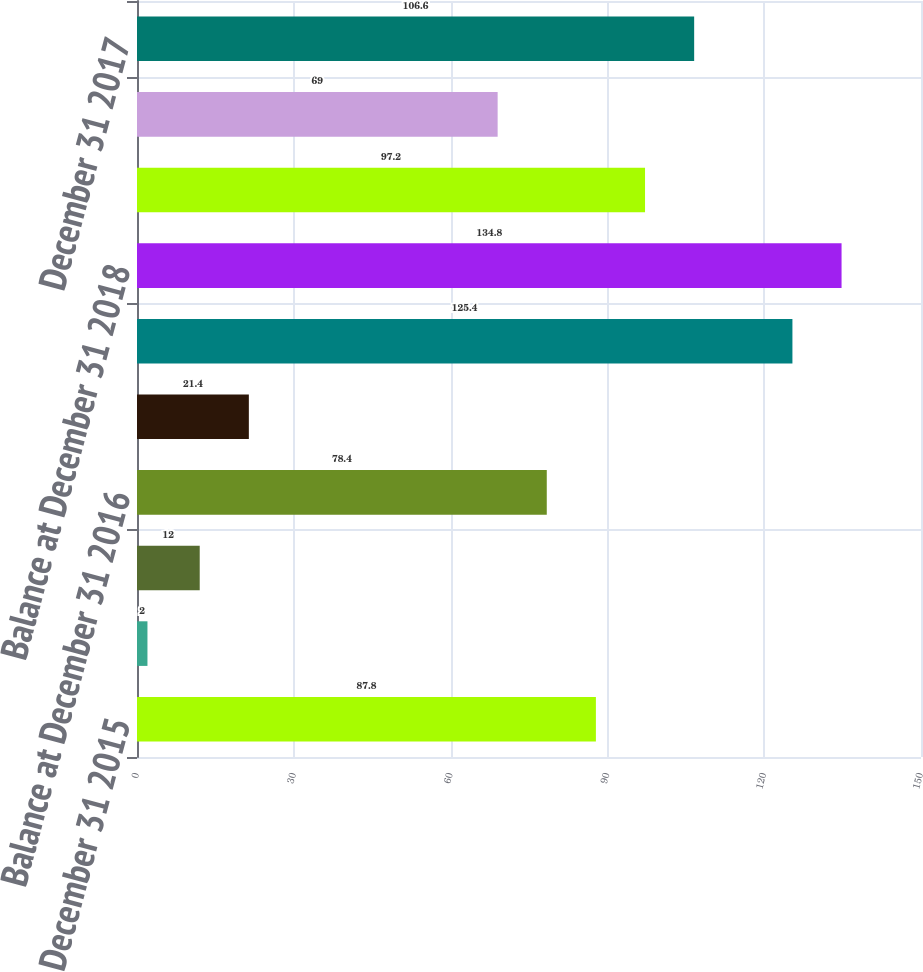Convert chart. <chart><loc_0><loc_0><loc_500><loc_500><bar_chart><fcel>Balance at December 31 2015<fcel>Improved recovery<fcel>Production<fcel>Balance at December 31 2016<fcel>Revisions of previous<fcel>Balance at December 31 2017<fcel>Balance at December 31 2018<fcel>December 31 2015<fcel>December 31 2016<fcel>December 31 2017<nl><fcel>87.8<fcel>2<fcel>12<fcel>78.4<fcel>21.4<fcel>125.4<fcel>134.8<fcel>97.2<fcel>69<fcel>106.6<nl></chart> 